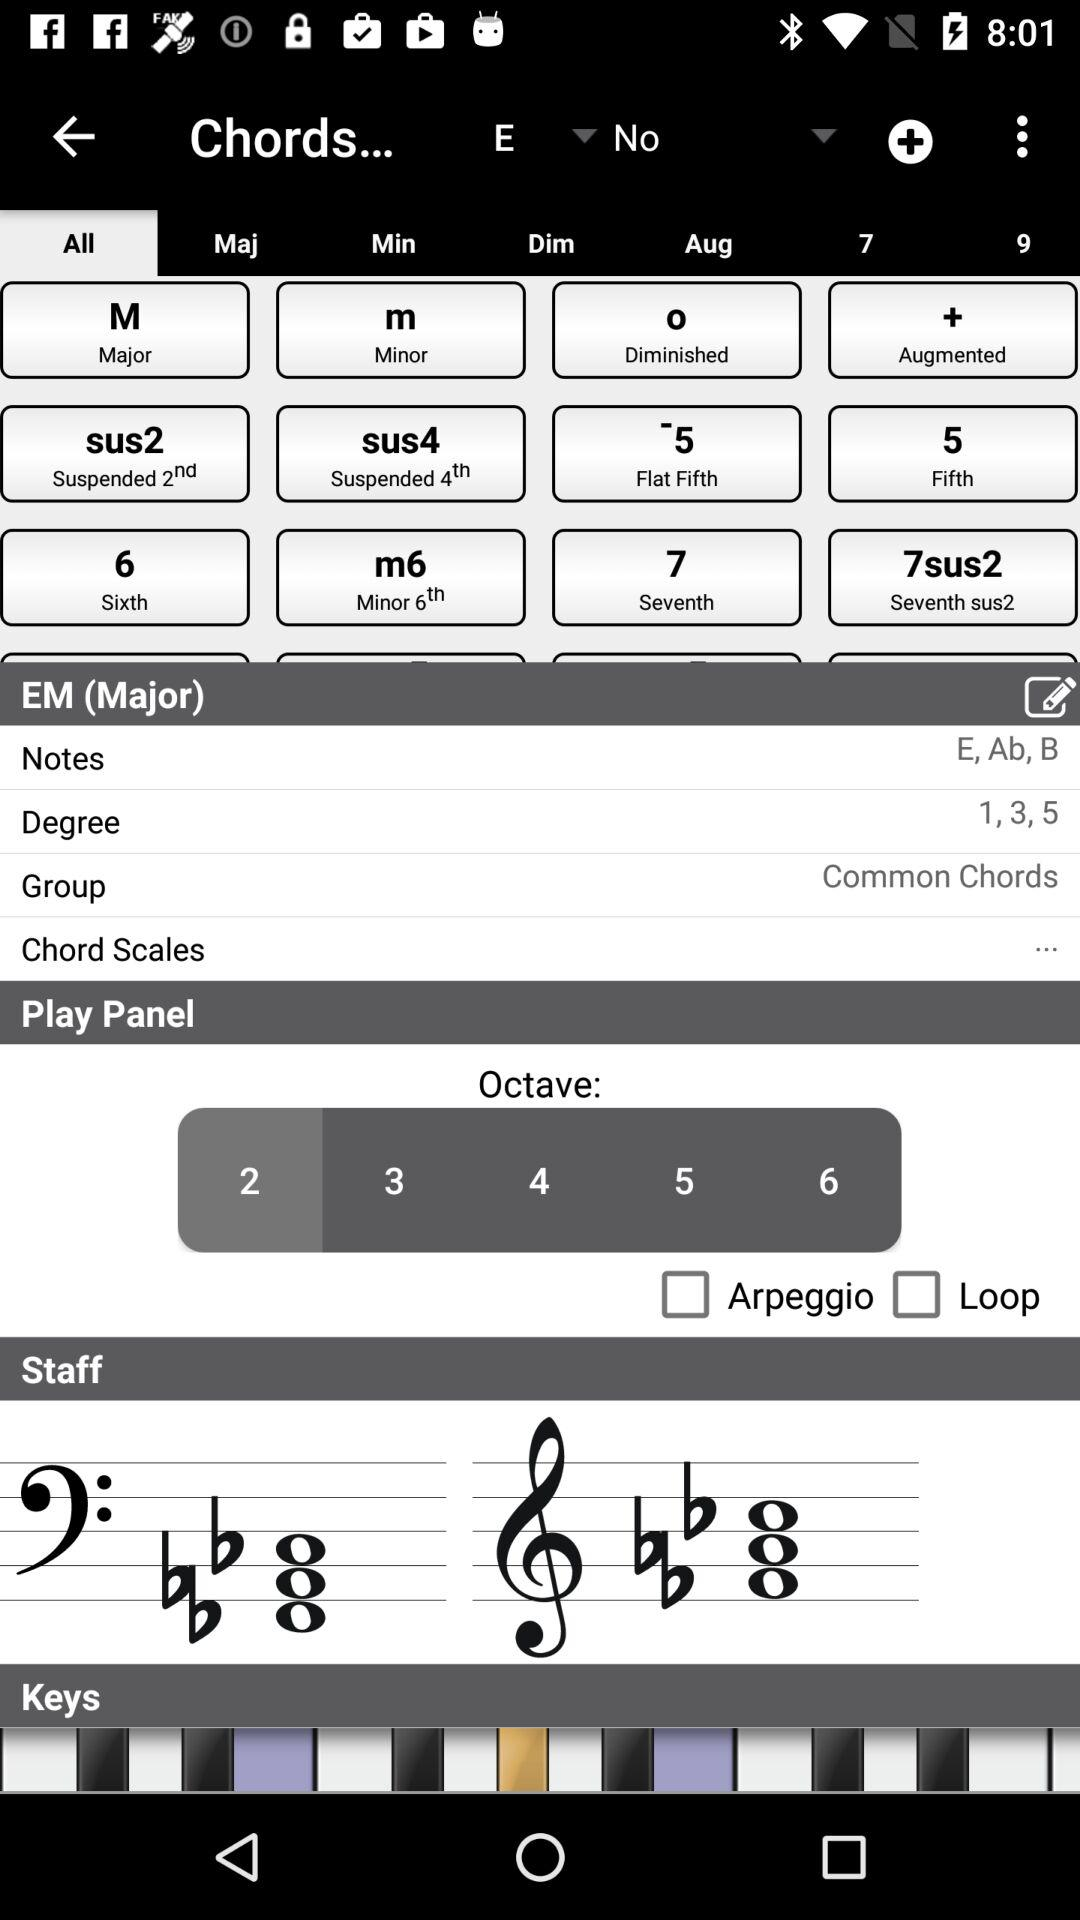What is the selected octave? The selected octave is 2. 